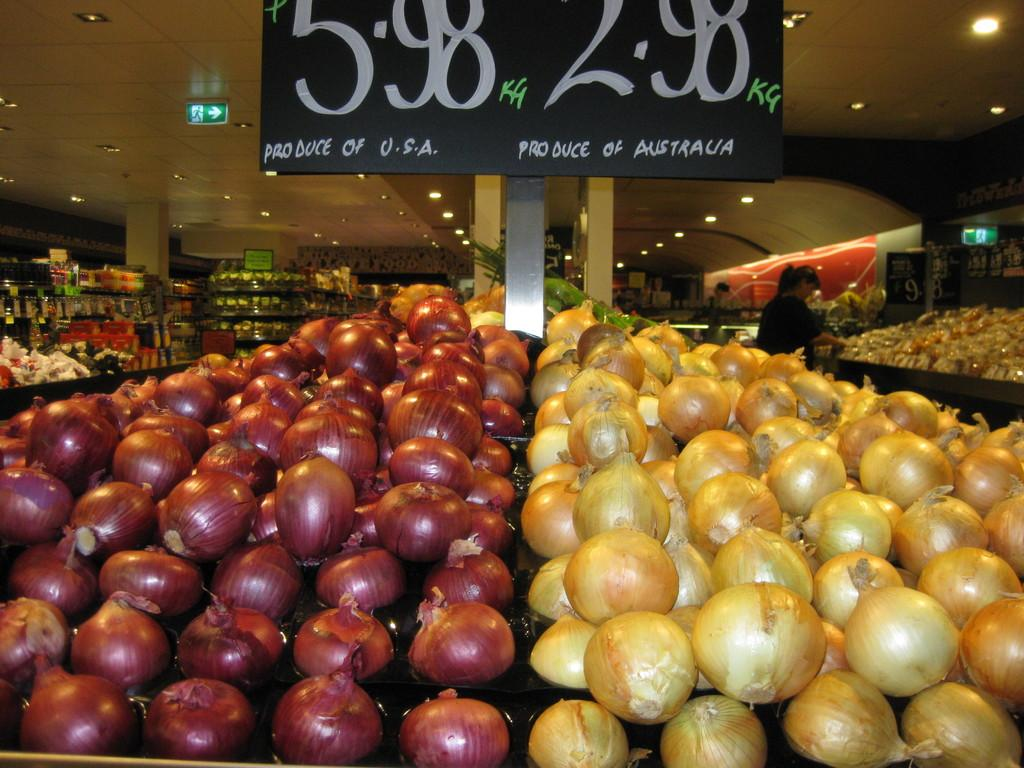What type of food items are visible in the image? There are different colors of onions in the image. What can be seen in the background of the image? There are vegetables and grocery products in the background of the image. What type of cork can be seen in the image? There is no cork present in the image. What causes the person in the image to feel shame? There is no person present in the image, so it is impossible to determine if they feel any emotions. 